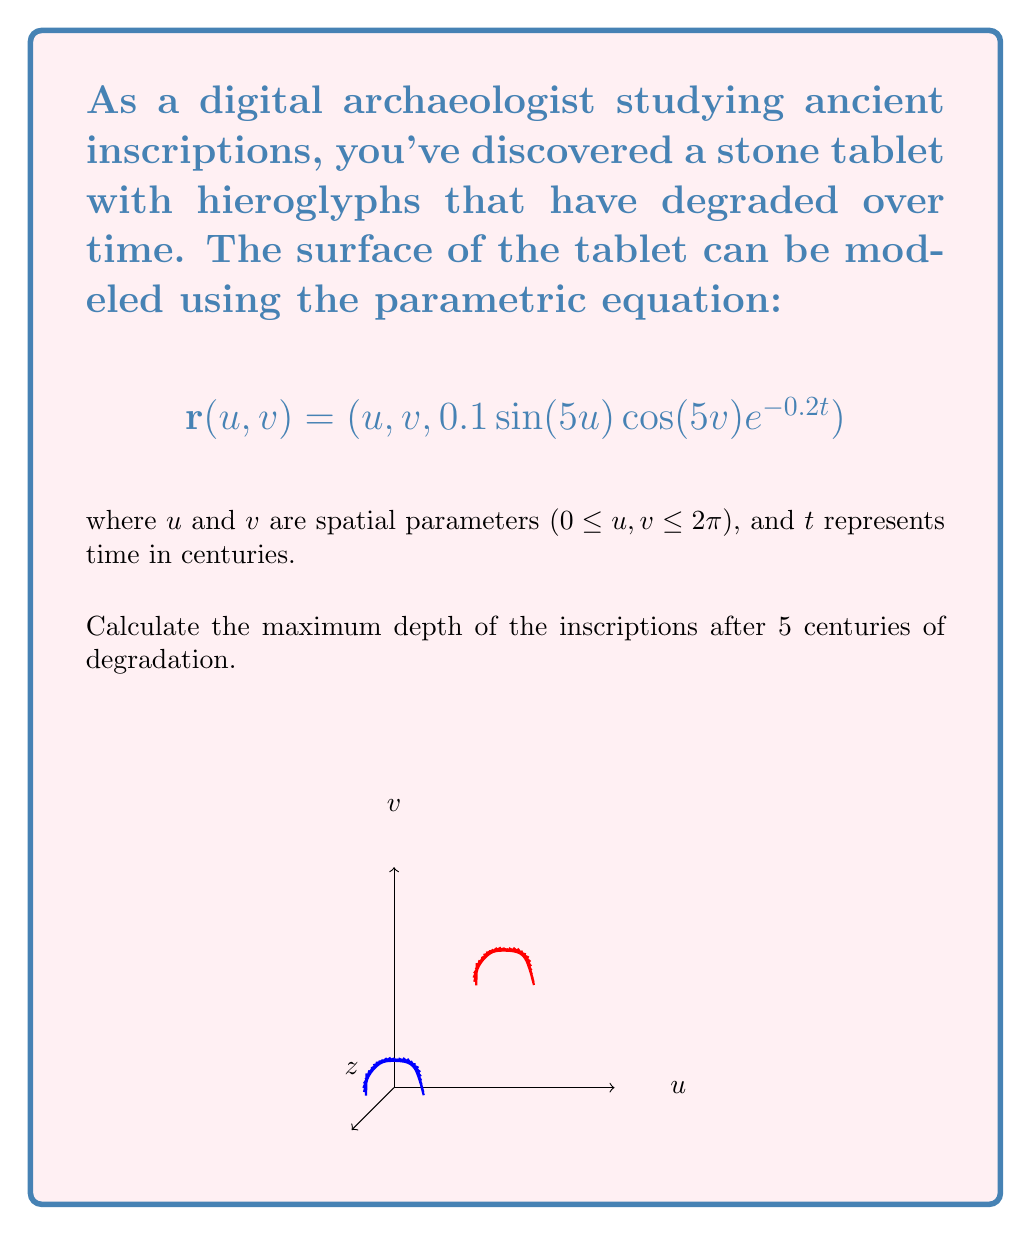Provide a solution to this math problem. Let's approach this step-by-step:

1) The depth of the inscriptions is represented by the z-component of the parametric equation:

   $$z = 0.1 \sin(5u) \cos(5v) e^{-0.2t}$$

2) The maximum depth will occur when $\sin(5u)$ and $\cos(5v)$ are at their extreme values, which is ±1 for both functions.

3) Therefore, the maximum depth function over time is:

   $$z_{max}(t) = 0.1 e^{-0.2t}$$

4) We need to evaluate this at $t = 5$ centuries:

   $$z_{max}(5) = 0.1 e^{-0.2(5)}$$

5) Let's calculate this:
   
   $$z_{max}(5) = 0.1 e^{-1} = 0.1 \cdot 0.3679 \approx 0.03679$$

6) The depth is measured in the same units as $u$ and $v$. If we assume these are in meters (which is reasonable for a stone tablet), then the maximum depth after 5 centuries would be approximately 0.03679 meters or 3.679 centimeters.
Answer: 0.03679 meters 